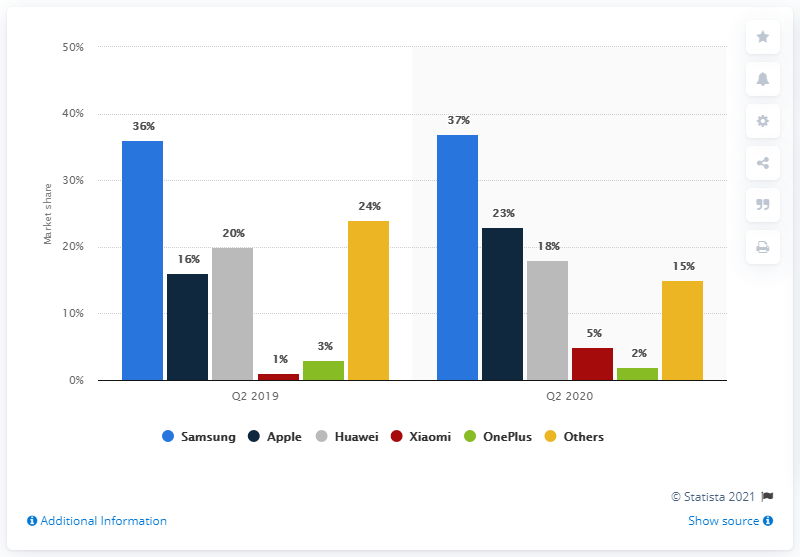Mention a couple of crucial points in this snapshot. In the second quarter of 2020, Apple held a 23% market share of the German smartphone market. Samsung is one of the most popular smartphones in Germany. 